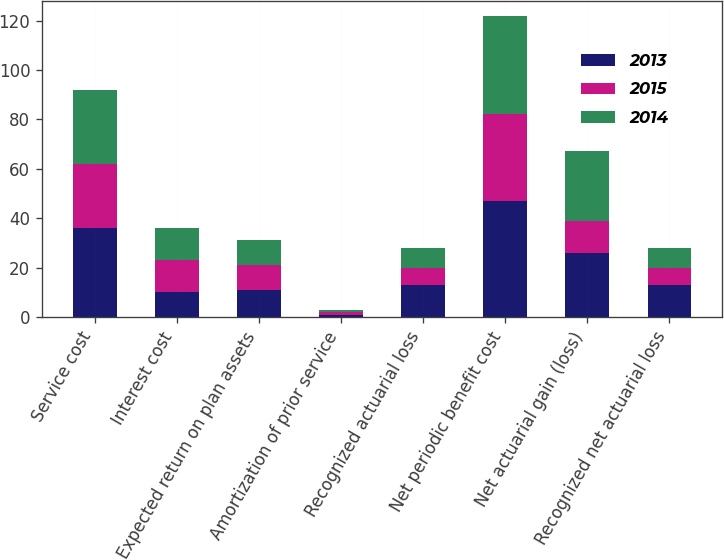Convert chart to OTSL. <chart><loc_0><loc_0><loc_500><loc_500><stacked_bar_chart><ecel><fcel>Service cost<fcel>Interest cost<fcel>Expected return on plan assets<fcel>Amortization of prior service<fcel>Recognized actuarial loss<fcel>Net periodic benefit cost<fcel>Net actuarial gain (loss)<fcel>Recognized net actuarial loss<nl><fcel>2013<fcel>36<fcel>10<fcel>11<fcel>1<fcel>13<fcel>47<fcel>26<fcel>13<nl><fcel>2015<fcel>26<fcel>13<fcel>10<fcel>1<fcel>7<fcel>35<fcel>13<fcel>7<nl><fcel>2014<fcel>30<fcel>13<fcel>10<fcel>1<fcel>8<fcel>40<fcel>28<fcel>8<nl></chart> 